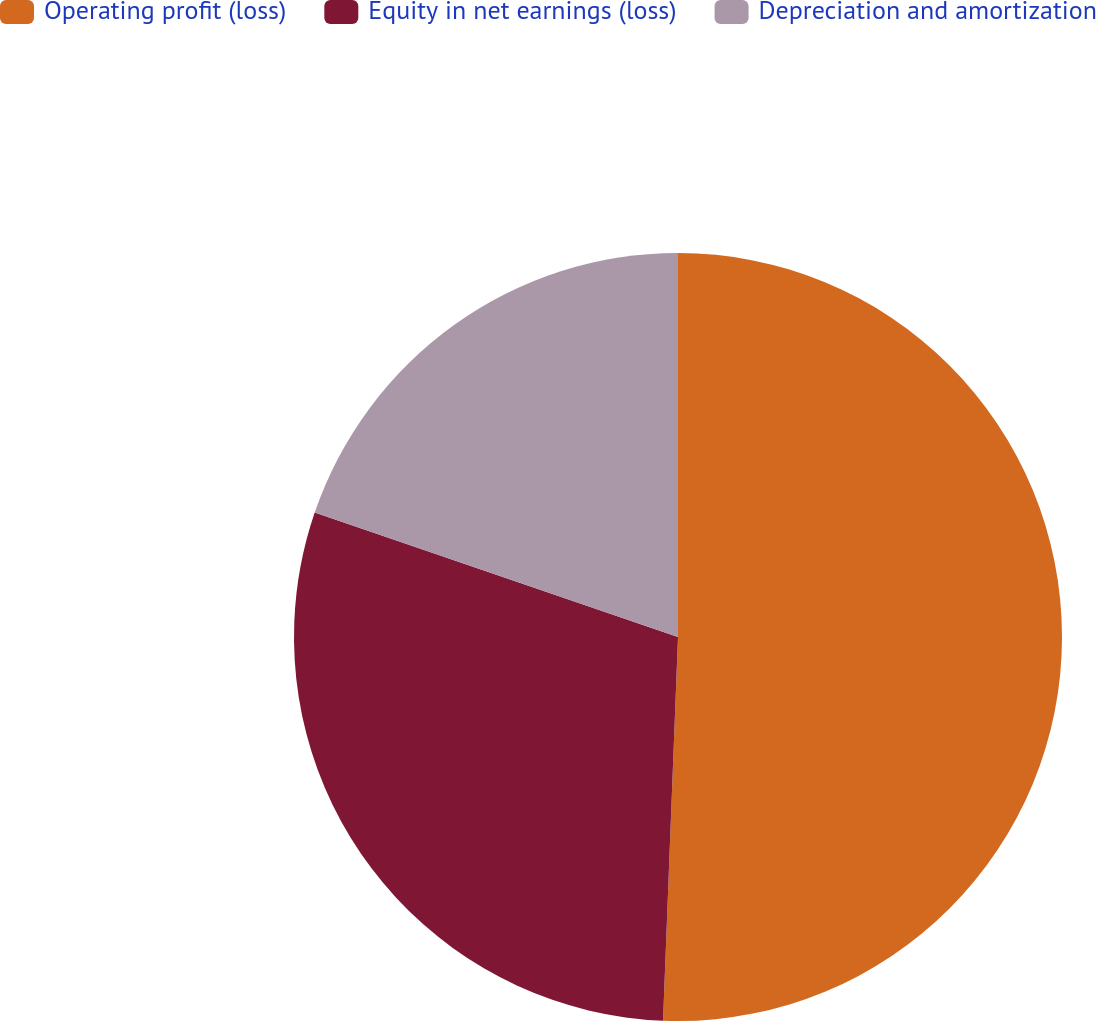<chart> <loc_0><loc_0><loc_500><loc_500><pie_chart><fcel>Operating profit (loss)<fcel>Equity in net earnings (loss)<fcel>Depreciation and amortization<nl><fcel>50.62%<fcel>29.63%<fcel>19.75%<nl></chart> 